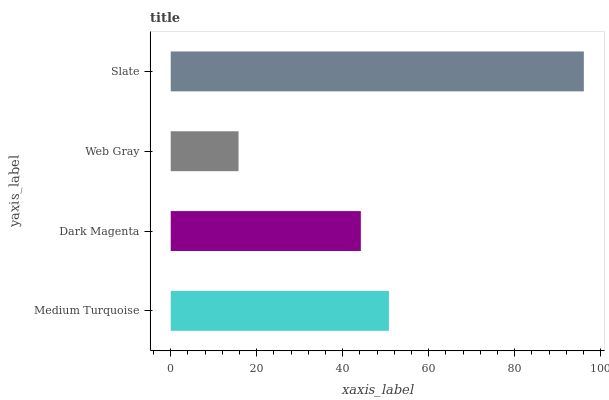Is Web Gray the minimum?
Answer yes or no. Yes. Is Slate the maximum?
Answer yes or no. Yes. Is Dark Magenta the minimum?
Answer yes or no. No. Is Dark Magenta the maximum?
Answer yes or no. No. Is Medium Turquoise greater than Dark Magenta?
Answer yes or no. Yes. Is Dark Magenta less than Medium Turquoise?
Answer yes or no. Yes. Is Dark Magenta greater than Medium Turquoise?
Answer yes or no. No. Is Medium Turquoise less than Dark Magenta?
Answer yes or no. No. Is Medium Turquoise the high median?
Answer yes or no. Yes. Is Dark Magenta the low median?
Answer yes or no. Yes. Is Slate the high median?
Answer yes or no. No. Is Web Gray the low median?
Answer yes or no. No. 